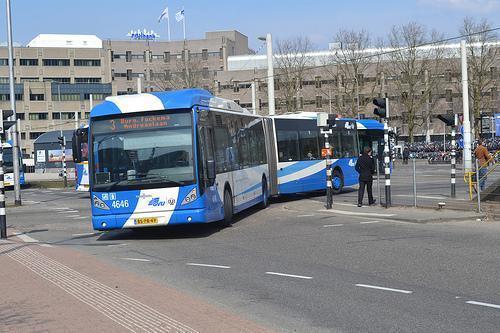How many flags are there?
Give a very brief answer. 2. 